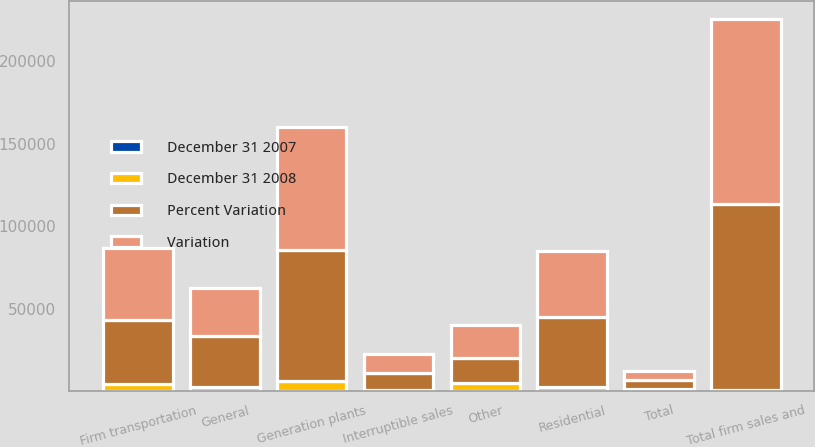Convert chart to OTSL. <chart><loc_0><loc_0><loc_500><loc_500><stacked_bar_chart><ecel><fcel>Residential<fcel>General<fcel>Firm transportation<fcel>Total firm sales and<fcel>Interruptible sales<fcel>Generation plants<fcel>Other<fcel>Total<nl><fcel>Variation<fcel>40195<fcel>28748<fcel>43245<fcel>112188<fcel>11220<fcel>74082<fcel>20004<fcel>5273<nl><fcel>Percent Variation<fcel>42573<fcel>31162<fcel>39016<fcel>112751<fcel>10577<fcel>79942<fcel>15318<fcel>5273<nl><fcel>December 31 2008<fcel>2378<fcel>2414<fcel>4229<fcel>563<fcel>643<fcel>5860<fcel>4686<fcel>1515<nl><fcel>December 31 2007<fcel>5.6<fcel>7.7<fcel>10.8<fcel>0.5<fcel>6.1<fcel>7.3<fcel>30.6<fcel>0.6<nl></chart> 